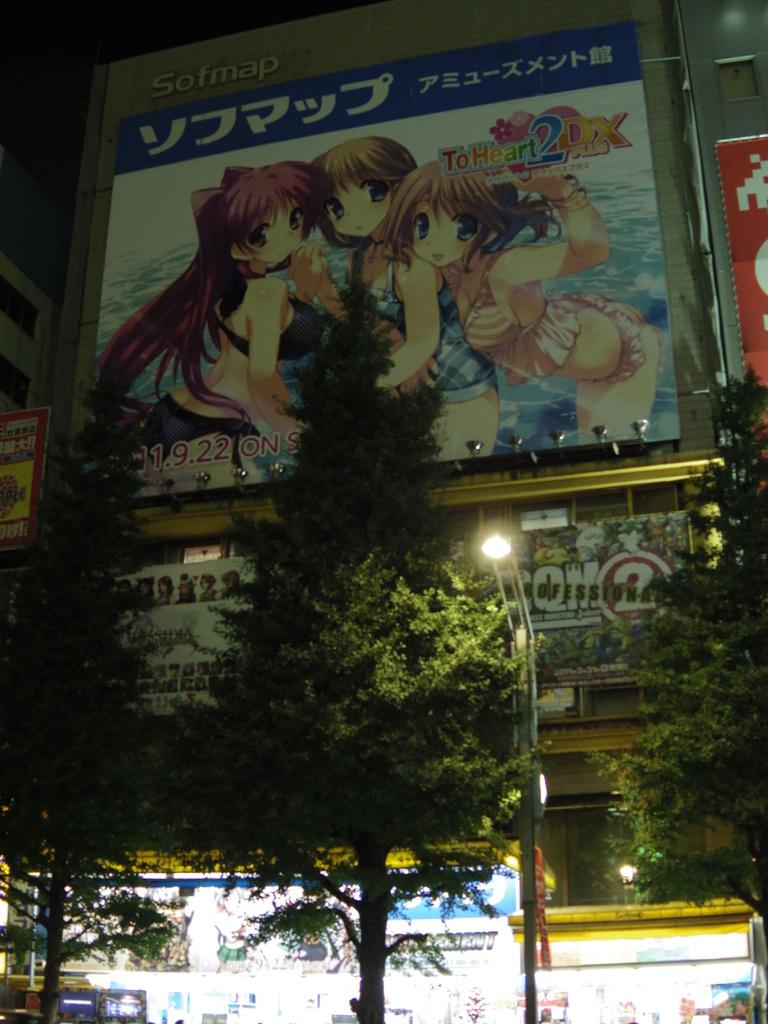What type of structures are present in the image? There are stalls and buildings in the image. What can be seen in front of the buildings? There are trees in front of the buildings. How many hydrants are visible in the image? There are no hydrants present in the image. What type of territory is depicted in the image? The image does not depict a specific territory; it simply shows stalls, buildings, and trees. 